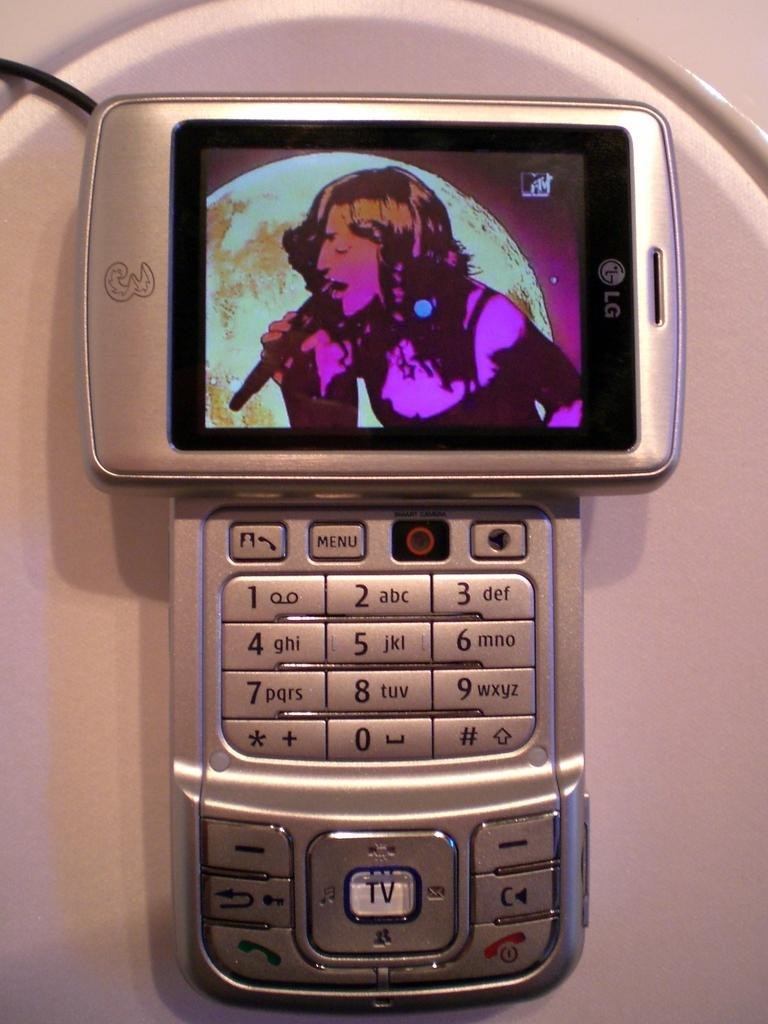<image>
Provide a brief description of the given image. A silver cell phone has a singer on the screen and says LG. 